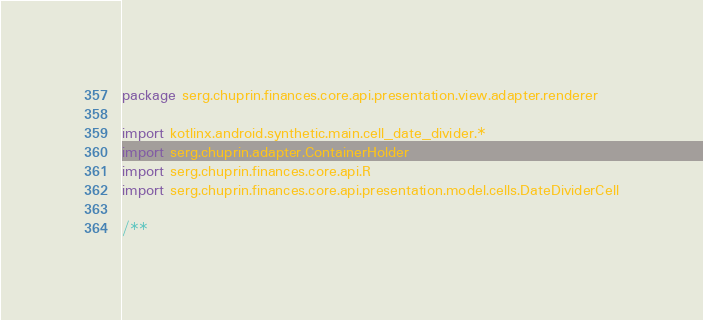Convert code to text. <code><loc_0><loc_0><loc_500><loc_500><_Kotlin_>package serg.chuprin.finances.core.api.presentation.view.adapter.renderer

import kotlinx.android.synthetic.main.cell_date_divider.*
import serg.chuprin.adapter.ContainerHolder
import serg.chuprin.finances.core.api.R
import serg.chuprin.finances.core.api.presentation.model.cells.DateDividerCell

/**</code> 